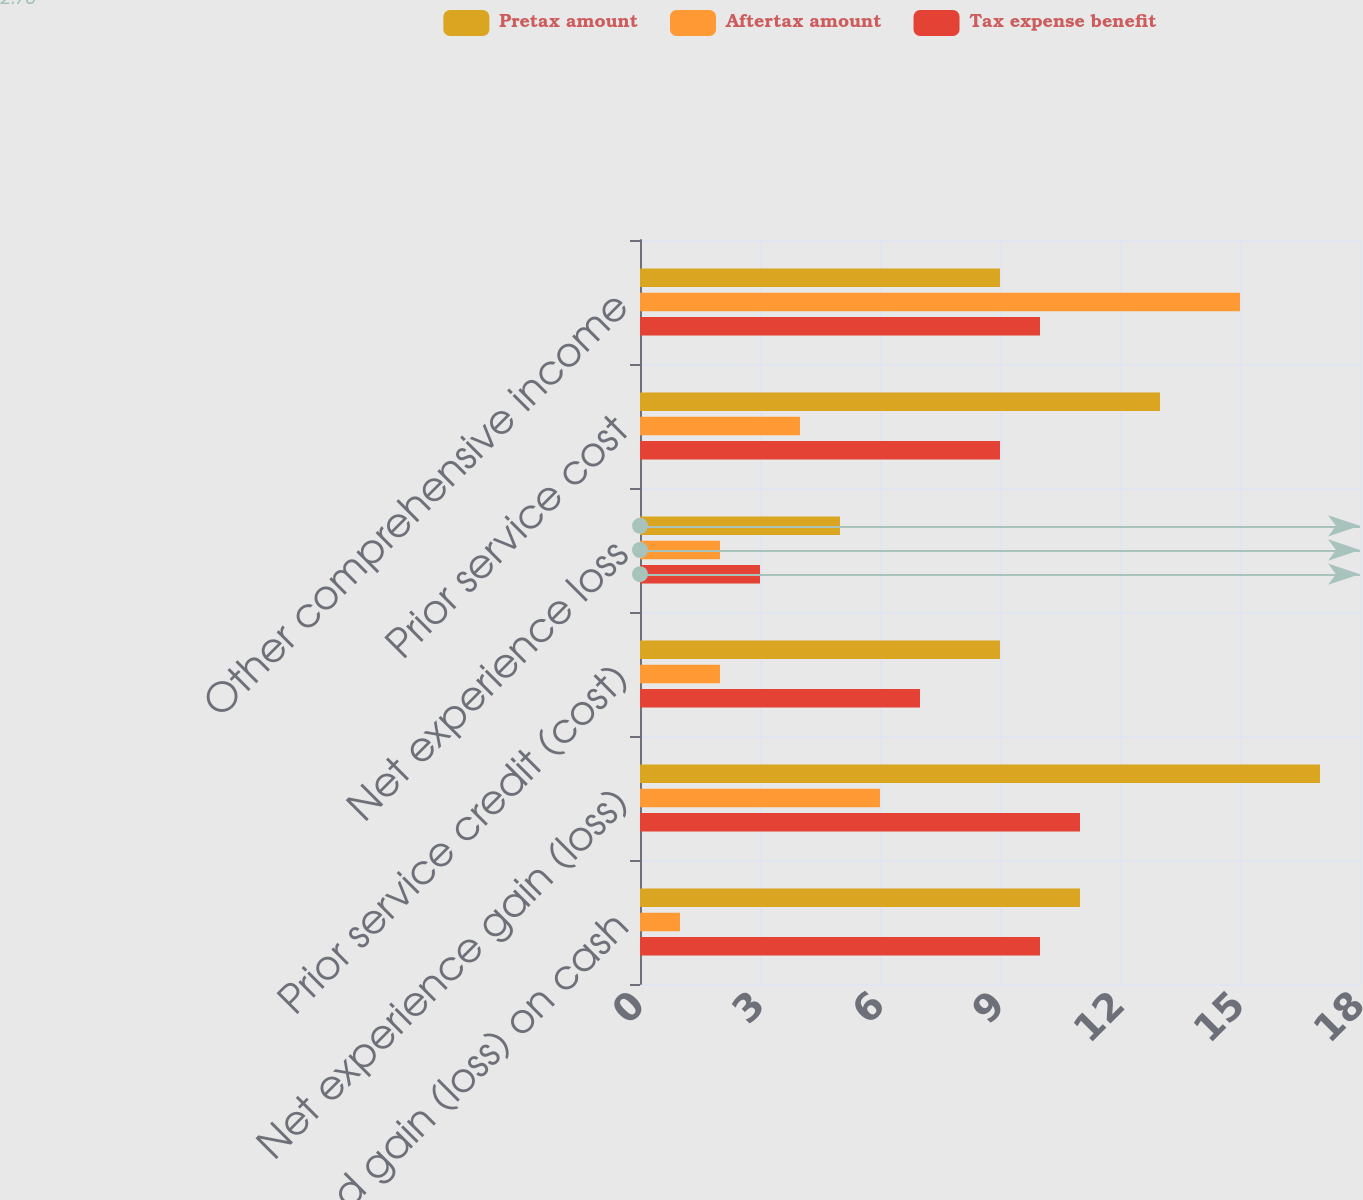<chart> <loc_0><loc_0><loc_500><loc_500><stacked_bar_chart><ecel><fcel>Unrealized gain (loss) on cash<fcel>Net experience gain (loss)<fcel>Prior service credit (cost)<fcel>Net experience loss<fcel>Prior service cost<fcel>Other comprehensive income<nl><fcel>Pretax amount<fcel>11<fcel>17<fcel>9<fcel>5<fcel>13<fcel>9<nl><fcel>Aftertax amount<fcel>1<fcel>6<fcel>2<fcel>2<fcel>4<fcel>15<nl><fcel>Tax expense benefit<fcel>10<fcel>11<fcel>7<fcel>3<fcel>9<fcel>10<nl></chart> 